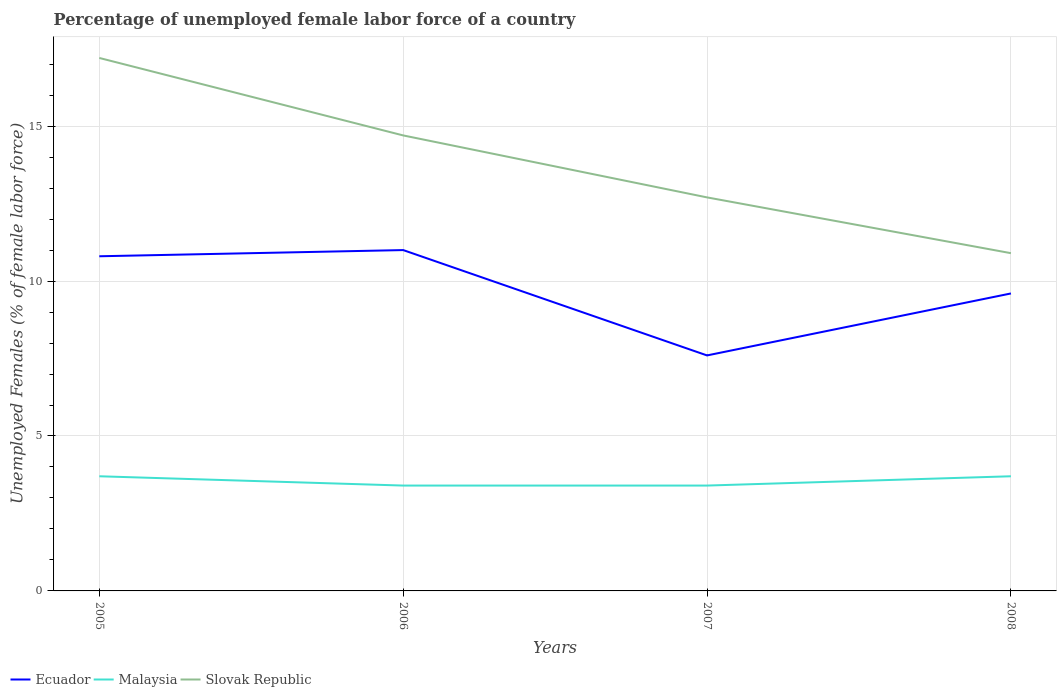Across all years, what is the maximum percentage of unemployed female labor force in Slovak Republic?
Your answer should be very brief. 10.9. What is the total percentage of unemployed female labor force in Ecuador in the graph?
Ensure brevity in your answer.  -0.2. What is the difference between the highest and the second highest percentage of unemployed female labor force in Malaysia?
Provide a short and direct response. 0.3. Is the percentage of unemployed female labor force in Ecuador strictly greater than the percentage of unemployed female labor force in Slovak Republic over the years?
Your answer should be compact. Yes. Does the graph contain any zero values?
Your response must be concise. No. Where does the legend appear in the graph?
Give a very brief answer. Bottom left. How many legend labels are there?
Provide a short and direct response. 3. How are the legend labels stacked?
Provide a succinct answer. Horizontal. What is the title of the graph?
Give a very brief answer. Percentage of unemployed female labor force of a country. What is the label or title of the X-axis?
Your answer should be very brief. Years. What is the label or title of the Y-axis?
Your response must be concise. Unemployed Females (% of female labor force). What is the Unemployed Females (% of female labor force) of Ecuador in 2005?
Keep it short and to the point. 10.8. What is the Unemployed Females (% of female labor force) of Malaysia in 2005?
Keep it short and to the point. 3.7. What is the Unemployed Females (% of female labor force) of Slovak Republic in 2005?
Provide a short and direct response. 17.2. What is the Unemployed Females (% of female labor force) in Malaysia in 2006?
Make the answer very short. 3.4. What is the Unemployed Females (% of female labor force) in Slovak Republic in 2006?
Provide a short and direct response. 14.7. What is the Unemployed Females (% of female labor force) in Ecuador in 2007?
Your answer should be compact. 7.6. What is the Unemployed Females (% of female labor force) in Malaysia in 2007?
Make the answer very short. 3.4. What is the Unemployed Females (% of female labor force) of Slovak Republic in 2007?
Provide a succinct answer. 12.7. What is the Unemployed Females (% of female labor force) of Ecuador in 2008?
Your response must be concise. 9.6. What is the Unemployed Females (% of female labor force) of Malaysia in 2008?
Your answer should be compact. 3.7. What is the Unemployed Females (% of female labor force) in Slovak Republic in 2008?
Provide a succinct answer. 10.9. Across all years, what is the maximum Unemployed Females (% of female labor force) of Ecuador?
Your response must be concise. 11. Across all years, what is the maximum Unemployed Females (% of female labor force) in Malaysia?
Your answer should be compact. 3.7. Across all years, what is the maximum Unemployed Females (% of female labor force) of Slovak Republic?
Provide a short and direct response. 17.2. Across all years, what is the minimum Unemployed Females (% of female labor force) of Ecuador?
Provide a short and direct response. 7.6. Across all years, what is the minimum Unemployed Females (% of female labor force) of Malaysia?
Your answer should be compact. 3.4. Across all years, what is the minimum Unemployed Females (% of female labor force) in Slovak Republic?
Keep it short and to the point. 10.9. What is the total Unemployed Females (% of female labor force) of Ecuador in the graph?
Make the answer very short. 39. What is the total Unemployed Females (% of female labor force) of Malaysia in the graph?
Give a very brief answer. 14.2. What is the total Unemployed Females (% of female labor force) in Slovak Republic in the graph?
Give a very brief answer. 55.5. What is the difference between the Unemployed Females (% of female labor force) in Ecuador in 2005 and that in 2006?
Keep it short and to the point. -0.2. What is the difference between the Unemployed Females (% of female labor force) in Ecuador in 2005 and that in 2007?
Give a very brief answer. 3.2. What is the difference between the Unemployed Females (% of female labor force) of Ecuador in 2006 and that in 2007?
Keep it short and to the point. 3.4. What is the difference between the Unemployed Females (% of female labor force) in Slovak Republic in 2006 and that in 2007?
Keep it short and to the point. 2. What is the difference between the Unemployed Females (% of female labor force) of Ecuador in 2006 and that in 2008?
Give a very brief answer. 1.4. What is the difference between the Unemployed Females (% of female labor force) of Slovak Republic in 2006 and that in 2008?
Your answer should be very brief. 3.8. What is the difference between the Unemployed Females (% of female labor force) of Ecuador in 2007 and that in 2008?
Offer a terse response. -2. What is the difference between the Unemployed Females (% of female labor force) of Slovak Republic in 2007 and that in 2008?
Your answer should be compact. 1.8. What is the difference between the Unemployed Females (% of female labor force) of Ecuador in 2005 and the Unemployed Females (% of female labor force) of Malaysia in 2007?
Offer a very short reply. 7.4. What is the difference between the Unemployed Females (% of female labor force) in Ecuador in 2005 and the Unemployed Females (% of female labor force) in Slovak Republic in 2007?
Keep it short and to the point. -1.9. What is the difference between the Unemployed Females (% of female labor force) of Ecuador in 2005 and the Unemployed Females (% of female labor force) of Slovak Republic in 2008?
Your answer should be very brief. -0.1. What is the difference between the Unemployed Females (% of female labor force) of Ecuador in 2006 and the Unemployed Females (% of female labor force) of Slovak Republic in 2007?
Provide a short and direct response. -1.7. What is the difference between the Unemployed Females (% of female labor force) of Malaysia in 2006 and the Unemployed Females (% of female labor force) of Slovak Republic in 2007?
Make the answer very short. -9.3. What is the difference between the Unemployed Females (% of female labor force) in Ecuador in 2006 and the Unemployed Females (% of female labor force) in Malaysia in 2008?
Provide a short and direct response. 7.3. What is the difference between the Unemployed Females (% of female labor force) of Ecuador in 2007 and the Unemployed Females (% of female labor force) of Slovak Republic in 2008?
Offer a very short reply. -3.3. What is the average Unemployed Females (% of female labor force) in Ecuador per year?
Make the answer very short. 9.75. What is the average Unemployed Females (% of female labor force) in Malaysia per year?
Offer a very short reply. 3.55. What is the average Unemployed Females (% of female labor force) in Slovak Republic per year?
Make the answer very short. 13.88. In the year 2005, what is the difference between the Unemployed Females (% of female labor force) in Ecuador and Unemployed Females (% of female labor force) in Malaysia?
Your response must be concise. 7.1. In the year 2005, what is the difference between the Unemployed Females (% of female labor force) in Ecuador and Unemployed Females (% of female labor force) in Slovak Republic?
Provide a succinct answer. -6.4. In the year 2006, what is the difference between the Unemployed Females (% of female labor force) in Malaysia and Unemployed Females (% of female labor force) in Slovak Republic?
Offer a very short reply. -11.3. In the year 2008, what is the difference between the Unemployed Females (% of female labor force) of Malaysia and Unemployed Females (% of female labor force) of Slovak Republic?
Your response must be concise. -7.2. What is the ratio of the Unemployed Females (% of female labor force) in Ecuador in 2005 to that in 2006?
Your answer should be compact. 0.98. What is the ratio of the Unemployed Females (% of female labor force) of Malaysia in 2005 to that in 2006?
Keep it short and to the point. 1.09. What is the ratio of the Unemployed Females (% of female labor force) in Slovak Republic in 2005 to that in 2006?
Your answer should be compact. 1.17. What is the ratio of the Unemployed Females (% of female labor force) of Ecuador in 2005 to that in 2007?
Keep it short and to the point. 1.42. What is the ratio of the Unemployed Females (% of female labor force) in Malaysia in 2005 to that in 2007?
Provide a succinct answer. 1.09. What is the ratio of the Unemployed Females (% of female labor force) of Slovak Republic in 2005 to that in 2007?
Keep it short and to the point. 1.35. What is the ratio of the Unemployed Females (% of female labor force) in Slovak Republic in 2005 to that in 2008?
Your answer should be very brief. 1.58. What is the ratio of the Unemployed Females (% of female labor force) of Ecuador in 2006 to that in 2007?
Keep it short and to the point. 1.45. What is the ratio of the Unemployed Females (% of female labor force) of Malaysia in 2006 to that in 2007?
Ensure brevity in your answer.  1. What is the ratio of the Unemployed Females (% of female labor force) of Slovak Republic in 2006 to that in 2007?
Your answer should be compact. 1.16. What is the ratio of the Unemployed Females (% of female labor force) in Ecuador in 2006 to that in 2008?
Offer a terse response. 1.15. What is the ratio of the Unemployed Females (% of female labor force) in Malaysia in 2006 to that in 2008?
Give a very brief answer. 0.92. What is the ratio of the Unemployed Females (% of female labor force) in Slovak Republic in 2006 to that in 2008?
Provide a succinct answer. 1.35. What is the ratio of the Unemployed Females (% of female labor force) in Ecuador in 2007 to that in 2008?
Offer a terse response. 0.79. What is the ratio of the Unemployed Females (% of female labor force) in Malaysia in 2007 to that in 2008?
Keep it short and to the point. 0.92. What is the ratio of the Unemployed Females (% of female labor force) of Slovak Republic in 2007 to that in 2008?
Offer a terse response. 1.17. 